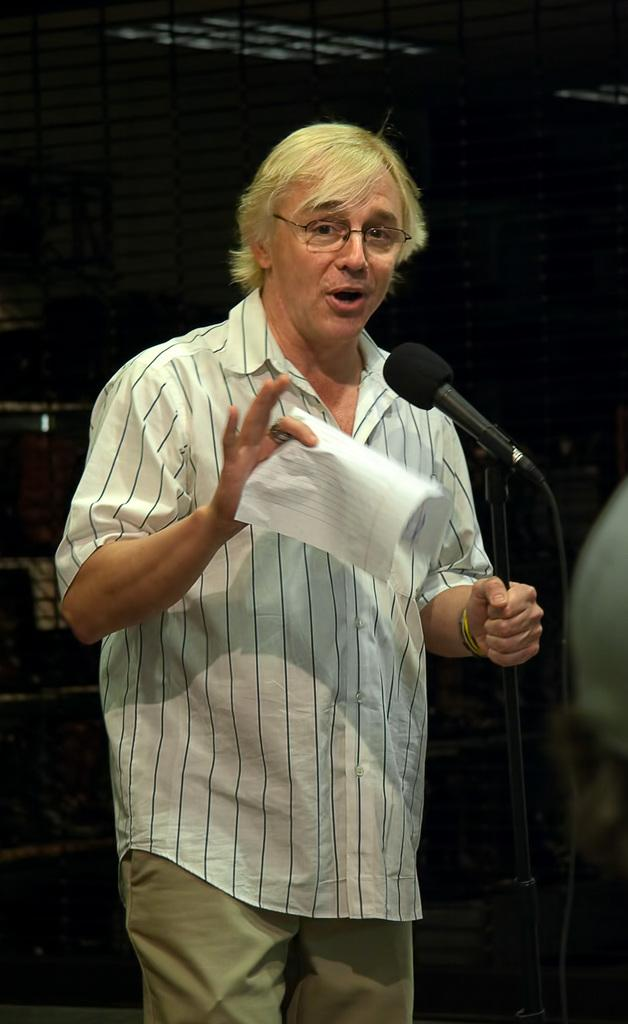Who is the main subject in the image? There is a man in the image. What is the man doing in the image? The man is standing near a microphone. What is the man holding in his hand? The man is holding paper in his hand. Can you describe the man's clothing in the image? The man is wearing a white shirt with lines on it. What type of clover is the man holding in his hand? There is no clover present in the image; the man is holding paper in his hand. 